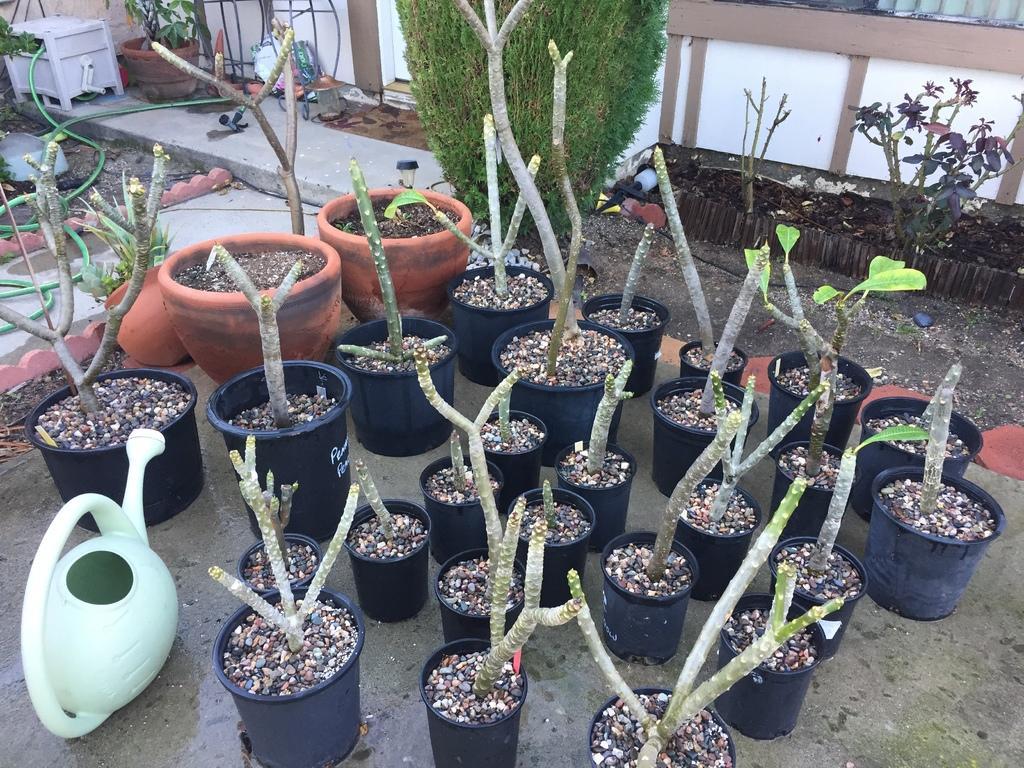Describe this image in one or two sentences. In this image I can see few plants in green color, at back I can see wall in white and brown color. 